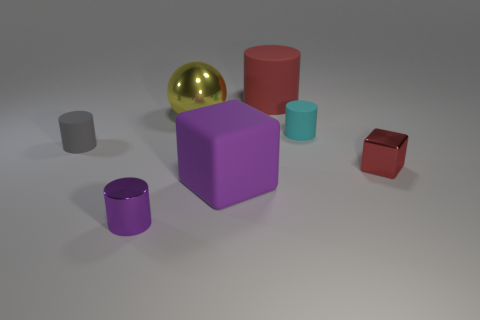How many objects are there in total in the image? There are a total of six objects in the image. Can you categorize them by shape? Certainly, there are two cylinders, one sphere, and three blocks in varying sizes. 